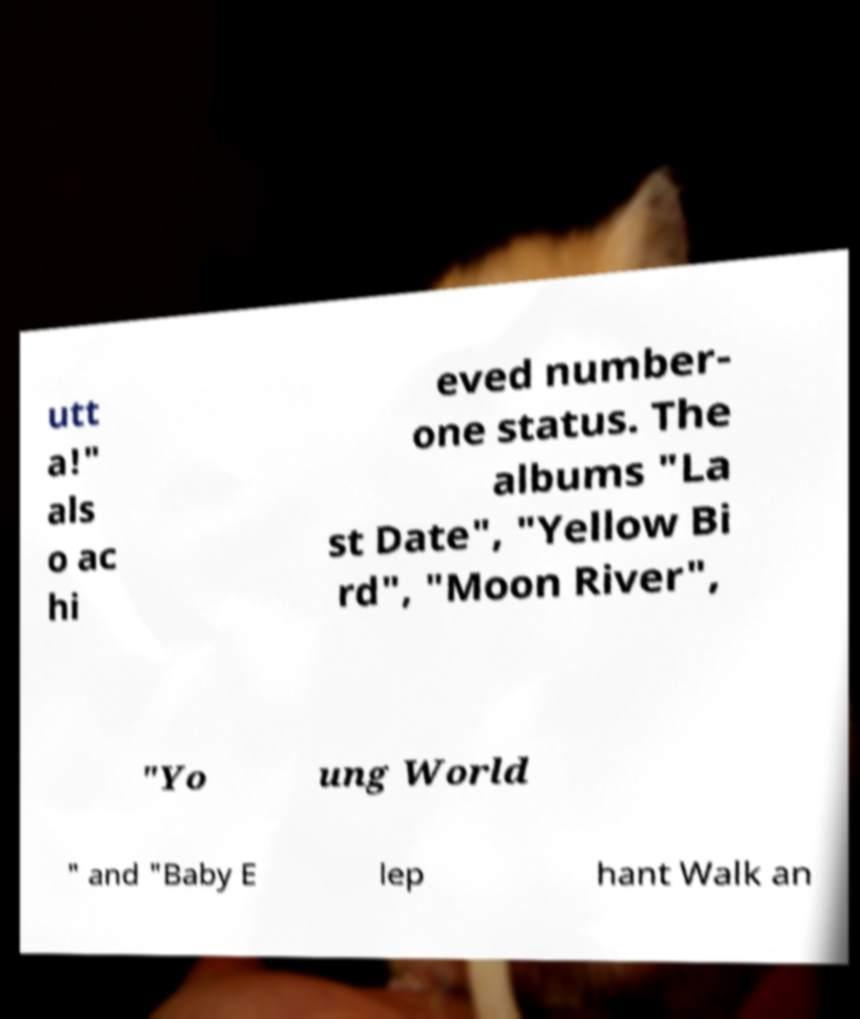Can you accurately transcribe the text from the provided image for me? utt a!" als o ac hi eved number- one status. The albums "La st Date", "Yellow Bi rd", "Moon River", "Yo ung World " and "Baby E lep hant Walk an 